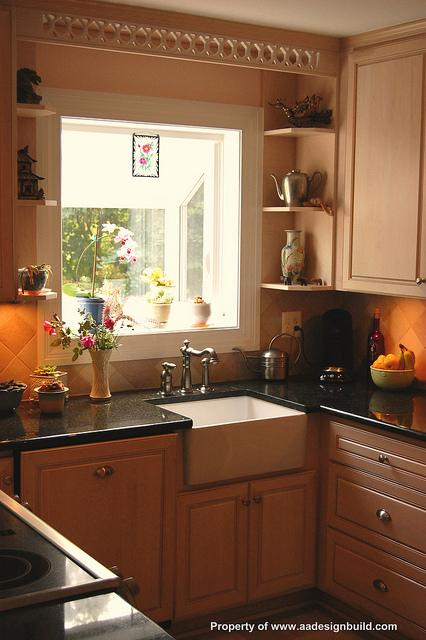What type of animals are shown on the lowest shelf to the right of the sink? Please explain your reasoning. elephants. Small statues of animals with long trunks are on a kitchen shelf. 